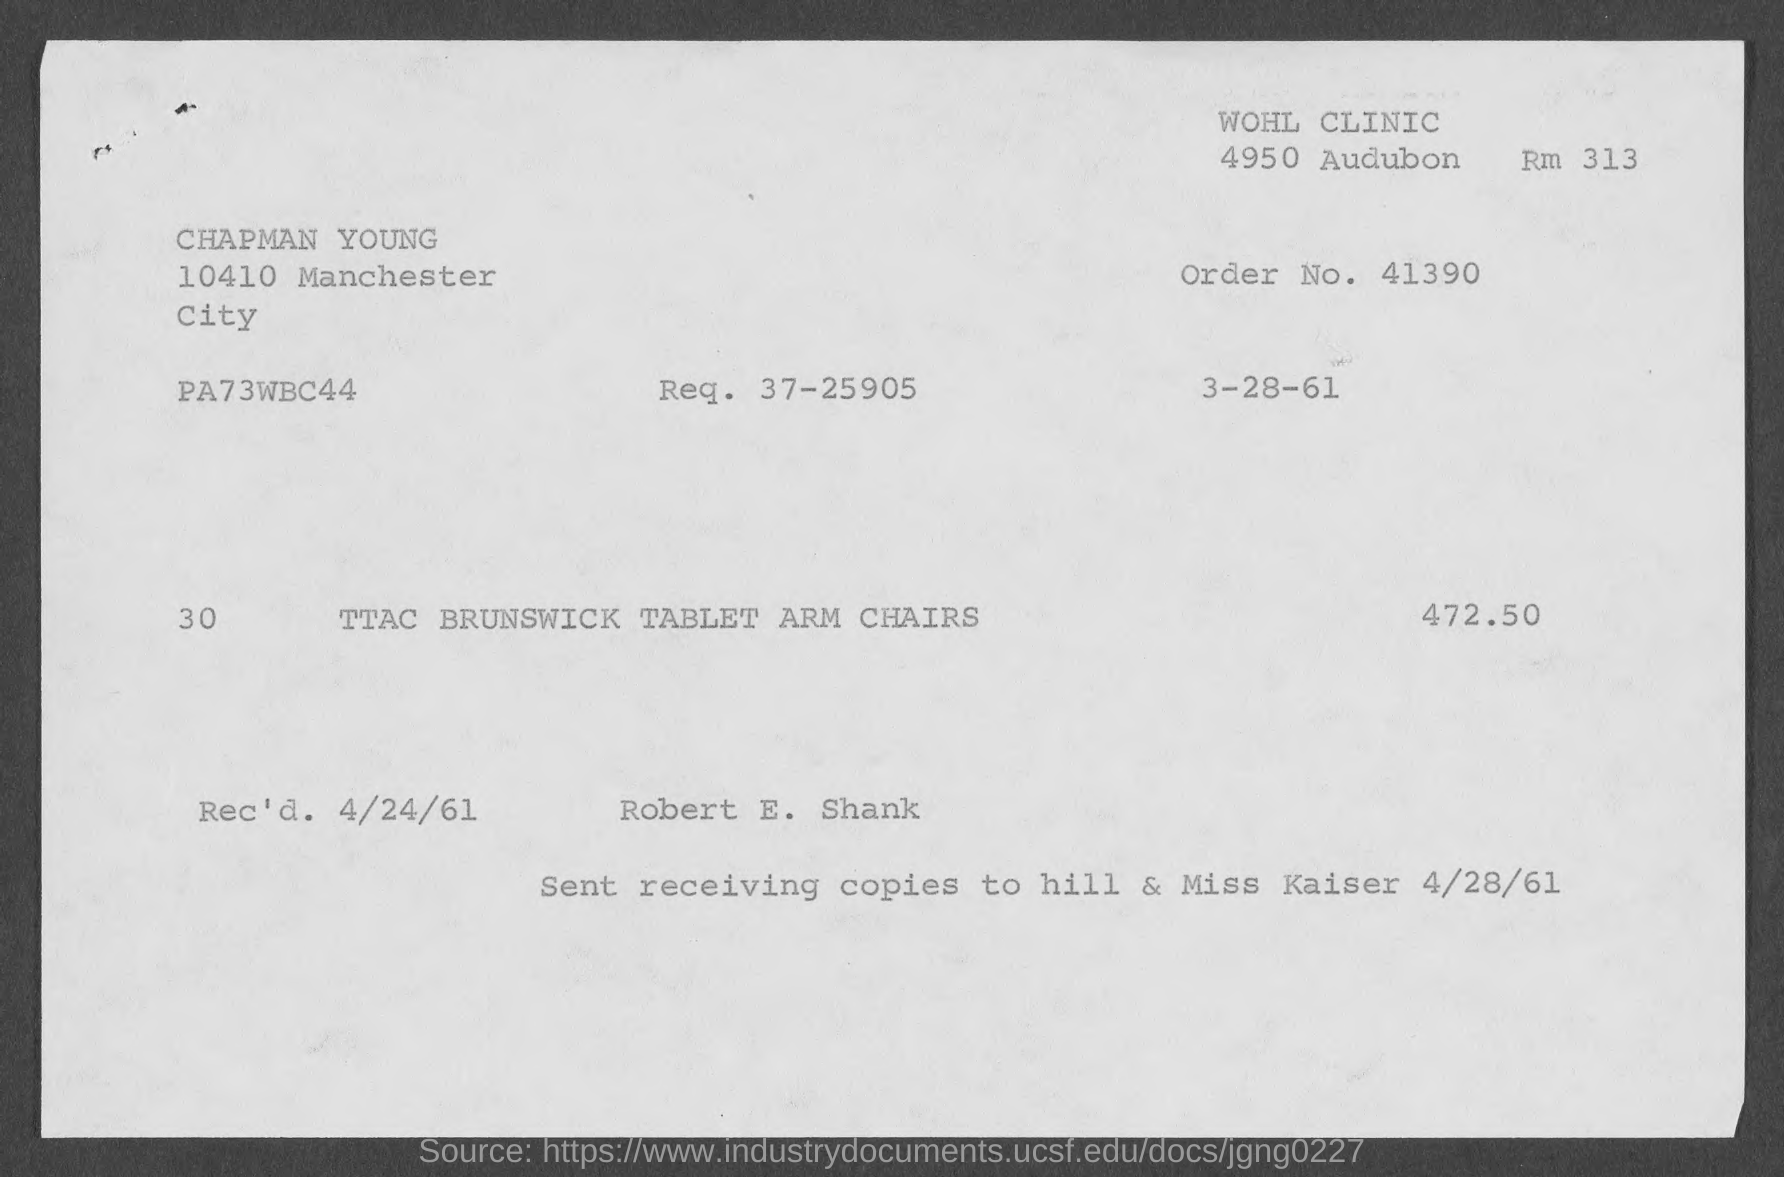What is the order no. mentioned in the given page ?
Offer a terse response. 41390. What is the req. no. mentioned in the given page ?
Make the answer very short. 37-25905. What is the amount mentioned in the given form ?
Give a very brief answer. 472.50. What is the rec'd date mentioned in the given page ?
Ensure brevity in your answer.  4/24/61. 